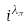Convert formula to latex. <formula><loc_0><loc_0><loc_500><loc_500>i ^ { \lambda _ { \pi } }</formula> 